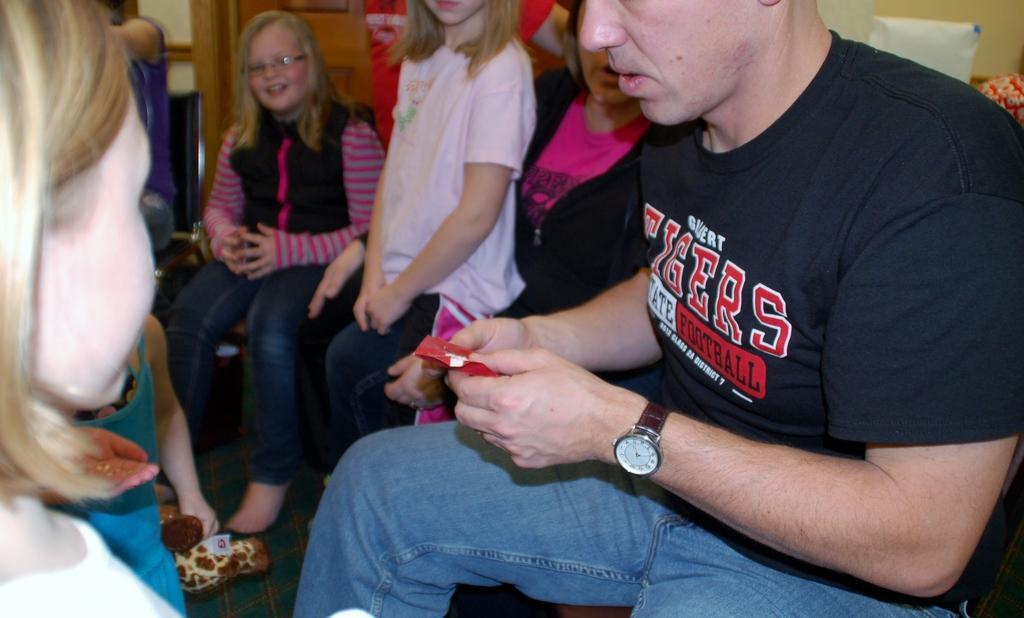Could you give a brief overview of what you see in this image? In this picture we can see some people sitting on chairs where a man holding a paper with his hands and in the background we can see the wall and some objects. 